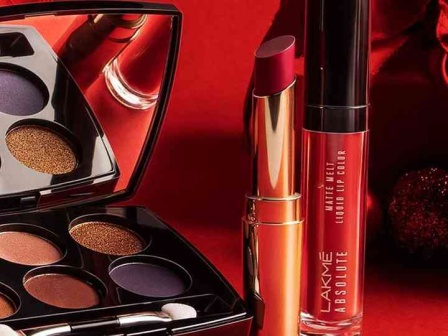If these makeup products were part of a magazine ad campaign, what might the tagline be? Embrace Your Glamour with Lakme: Where Bold Meets Elegance. 